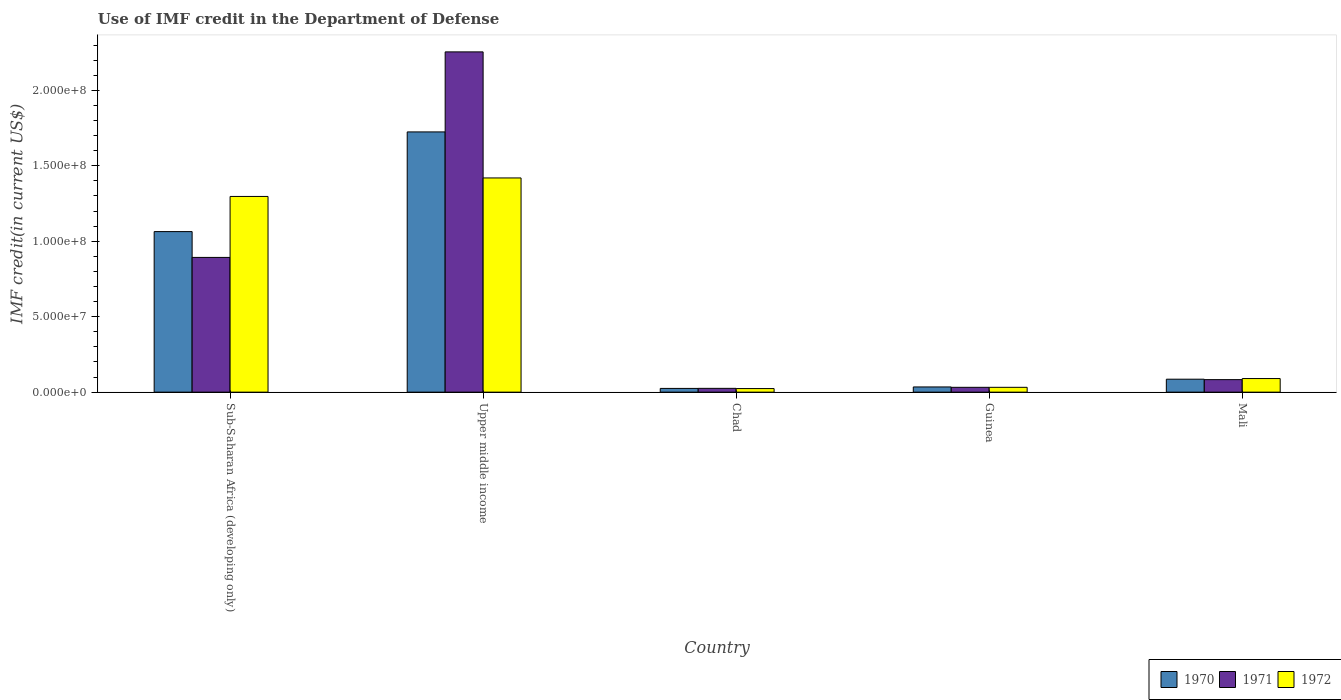Are the number of bars per tick equal to the number of legend labels?
Provide a succinct answer. Yes. Are the number of bars on each tick of the X-axis equal?
Your answer should be very brief. Yes. How many bars are there on the 2nd tick from the left?
Your answer should be compact. 3. What is the label of the 2nd group of bars from the left?
Your answer should be compact. Upper middle income. What is the IMF credit in the Department of Defense in 1972 in Upper middle income?
Keep it short and to the point. 1.42e+08. Across all countries, what is the maximum IMF credit in the Department of Defense in 1972?
Provide a short and direct response. 1.42e+08. Across all countries, what is the minimum IMF credit in the Department of Defense in 1970?
Provide a short and direct response. 2.47e+06. In which country was the IMF credit in the Department of Defense in 1971 maximum?
Offer a terse response. Upper middle income. In which country was the IMF credit in the Department of Defense in 1972 minimum?
Provide a succinct answer. Chad. What is the total IMF credit in the Department of Defense in 1970 in the graph?
Your response must be concise. 2.93e+08. What is the difference between the IMF credit in the Department of Defense in 1971 in Guinea and that in Mali?
Keep it short and to the point. -5.09e+06. What is the difference between the IMF credit in the Department of Defense in 1970 in Sub-Saharan Africa (developing only) and the IMF credit in the Department of Defense in 1971 in Mali?
Offer a very short reply. 9.81e+07. What is the average IMF credit in the Department of Defense in 1970 per country?
Ensure brevity in your answer.  5.87e+07. What is the difference between the IMF credit in the Department of Defense of/in 1971 and IMF credit in the Department of Defense of/in 1972 in Chad?
Your response must be concise. 1.52e+05. In how many countries, is the IMF credit in the Department of Defense in 1971 greater than 70000000 US$?
Offer a very short reply. 2. What is the ratio of the IMF credit in the Department of Defense in 1971 in Chad to that in Sub-Saharan Africa (developing only)?
Provide a short and direct response. 0.03. What is the difference between the highest and the second highest IMF credit in the Department of Defense in 1971?
Keep it short and to the point. 1.36e+08. What is the difference between the highest and the lowest IMF credit in the Department of Defense in 1972?
Your answer should be very brief. 1.40e+08. In how many countries, is the IMF credit in the Department of Defense in 1971 greater than the average IMF credit in the Department of Defense in 1971 taken over all countries?
Your answer should be compact. 2. What does the 3rd bar from the left in Guinea represents?
Make the answer very short. 1972. Are all the bars in the graph horizontal?
Keep it short and to the point. No. What is the difference between two consecutive major ticks on the Y-axis?
Provide a short and direct response. 5.00e+07. Are the values on the major ticks of Y-axis written in scientific E-notation?
Your response must be concise. Yes. Does the graph contain grids?
Your answer should be very brief. No. Where does the legend appear in the graph?
Offer a terse response. Bottom right. How are the legend labels stacked?
Provide a short and direct response. Horizontal. What is the title of the graph?
Your answer should be very brief. Use of IMF credit in the Department of Defense. What is the label or title of the Y-axis?
Your answer should be very brief. IMF credit(in current US$). What is the IMF credit(in current US$) of 1970 in Sub-Saharan Africa (developing only)?
Offer a terse response. 1.06e+08. What is the IMF credit(in current US$) of 1971 in Sub-Saharan Africa (developing only)?
Your answer should be very brief. 8.93e+07. What is the IMF credit(in current US$) of 1972 in Sub-Saharan Africa (developing only)?
Your answer should be compact. 1.30e+08. What is the IMF credit(in current US$) in 1970 in Upper middle income?
Your answer should be compact. 1.72e+08. What is the IMF credit(in current US$) of 1971 in Upper middle income?
Offer a terse response. 2.25e+08. What is the IMF credit(in current US$) in 1972 in Upper middle income?
Provide a succinct answer. 1.42e+08. What is the IMF credit(in current US$) of 1970 in Chad?
Provide a short and direct response. 2.47e+06. What is the IMF credit(in current US$) of 1971 in Chad?
Keep it short and to the point. 2.52e+06. What is the IMF credit(in current US$) in 1972 in Chad?
Make the answer very short. 2.37e+06. What is the IMF credit(in current US$) in 1970 in Guinea?
Provide a short and direct response. 3.45e+06. What is the IMF credit(in current US$) of 1971 in Guinea?
Your response must be concise. 3.20e+06. What is the IMF credit(in current US$) of 1972 in Guinea?
Ensure brevity in your answer.  3.20e+06. What is the IMF credit(in current US$) of 1970 in Mali?
Keep it short and to the point. 8.58e+06. What is the IMF credit(in current US$) in 1971 in Mali?
Ensure brevity in your answer.  8.30e+06. What is the IMF credit(in current US$) in 1972 in Mali?
Your answer should be very brief. 9.01e+06. Across all countries, what is the maximum IMF credit(in current US$) in 1970?
Offer a very short reply. 1.72e+08. Across all countries, what is the maximum IMF credit(in current US$) in 1971?
Your answer should be very brief. 2.25e+08. Across all countries, what is the maximum IMF credit(in current US$) in 1972?
Provide a succinct answer. 1.42e+08. Across all countries, what is the minimum IMF credit(in current US$) of 1970?
Offer a terse response. 2.47e+06. Across all countries, what is the minimum IMF credit(in current US$) in 1971?
Offer a terse response. 2.52e+06. Across all countries, what is the minimum IMF credit(in current US$) in 1972?
Make the answer very short. 2.37e+06. What is the total IMF credit(in current US$) in 1970 in the graph?
Your answer should be compact. 2.93e+08. What is the total IMF credit(in current US$) of 1971 in the graph?
Your response must be concise. 3.29e+08. What is the total IMF credit(in current US$) in 1972 in the graph?
Provide a succinct answer. 2.86e+08. What is the difference between the IMF credit(in current US$) in 1970 in Sub-Saharan Africa (developing only) and that in Upper middle income?
Your answer should be compact. -6.61e+07. What is the difference between the IMF credit(in current US$) in 1971 in Sub-Saharan Africa (developing only) and that in Upper middle income?
Your response must be concise. -1.36e+08. What is the difference between the IMF credit(in current US$) in 1972 in Sub-Saharan Africa (developing only) and that in Upper middle income?
Offer a terse response. -1.23e+07. What is the difference between the IMF credit(in current US$) of 1970 in Sub-Saharan Africa (developing only) and that in Chad?
Your response must be concise. 1.04e+08. What is the difference between the IMF credit(in current US$) of 1971 in Sub-Saharan Africa (developing only) and that in Chad?
Your response must be concise. 8.68e+07. What is the difference between the IMF credit(in current US$) of 1972 in Sub-Saharan Africa (developing only) and that in Chad?
Offer a terse response. 1.27e+08. What is the difference between the IMF credit(in current US$) of 1970 in Sub-Saharan Africa (developing only) and that in Guinea?
Provide a short and direct response. 1.03e+08. What is the difference between the IMF credit(in current US$) in 1971 in Sub-Saharan Africa (developing only) and that in Guinea?
Keep it short and to the point. 8.61e+07. What is the difference between the IMF credit(in current US$) of 1972 in Sub-Saharan Africa (developing only) and that in Guinea?
Give a very brief answer. 1.26e+08. What is the difference between the IMF credit(in current US$) in 1970 in Sub-Saharan Africa (developing only) and that in Mali?
Provide a succinct answer. 9.78e+07. What is the difference between the IMF credit(in current US$) in 1971 in Sub-Saharan Africa (developing only) and that in Mali?
Offer a very short reply. 8.10e+07. What is the difference between the IMF credit(in current US$) of 1972 in Sub-Saharan Africa (developing only) and that in Mali?
Offer a very short reply. 1.21e+08. What is the difference between the IMF credit(in current US$) of 1970 in Upper middle income and that in Chad?
Make the answer very short. 1.70e+08. What is the difference between the IMF credit(in current US$) of 1971 in Upper middle income and that in Chad?
Keep it short and to the point. 2.23e+08. What is the difference between the IMF credit(in current US$) of 1972 in Upper middle income and that in Chad?
Ensure brevity in your answer.  1.40e+08. What is the difference between the IMF credit(in current US$) in 1970 in Upper middle income and that in Guinea?
Make the answer very short. 1.69e+08. What is the difference between the IMF credit(in current US$) in 1971 in Upper middle income and that in Guinea?
Offer a very short reply. 2.22e+08. What is the difference between the IMF credit(in current US$) of 1972 in Upper middle income and that in Guinea?
Your answer should be very brief. 1.39e+08. What is the difference between the IMF credit(in current US$) of 1970 in Upper middle income and that in Mali?
Keep it short and to the point. 1.64e+08. What is the difference between the IMF credit(in current US$) in 1971 in Upper middle income and that in Mali?
Ensure brevity in your answer.  2.17e+08. What is the difference between the IMF credit(in current US$) of 1972 in Upper middle income and that in Mali?
Keep it short and to the point. 1.33e+08. What is the difference between the IMF credit(in current US$) in 1970 in Chad and that in Guinea?
Your answer should be very brief. -9.80e+05. What is the difference between the IMF credit(in current US$) in 1971 in Chad and that in Guinea?
Ensure brevity in your answer.  -6.84e+05. What is the difference between the IMF credit(in current US$) in 1972 in Chad and that in Guinea?
Your response must be concise. -8.36e+05. What is the difference between the IMF credit(in current US$) in 1970 in Chad and that in Mali?
Keep it short and to the point. -6.11e+06. What is the difference between the IMF credit(in current US$) in 1971 in Chad and that in Mali?
Offer a terse response. -5.78e+06. What is the difference between the IMF credit(in current US$) in 1972 in Chad and that in Mali?
Your response must be concise. -6.64e+06. What is the difference between the IMF credit(in current US$) in 1970 in Guinea and that in Mali?
Make the answer very short. -5.13e+06. What is the difference between the IMF credit(in current US$) in 1971 in Guinea and that in Mali?
Your response must be concise. -5.09e+06. What is the difference between the IMF credit(in current US$) of 1972 in Guinea and that in Mali?
Give a very brief answer. -5.81e+06. What is the difference between the IMF credit(in current US$) of 1970 in Sub-Saharan Africa (developing only) and the IMF credit(in current US$) of 1971 in Upper middle income?
Make the answer very short. -1.19e+08. What is the difference between the IMF credit(in current US$) in 1970 in Sub-Saharan Africa (developing only) and the IMF credit(in current US$) in 1972 in Upper middle income?
Keep it short and to the point. -3.56e+07. What is the difference between the IMF credit(in current US$) in 1971 in Sub-Saharan Africa (developing only) and the IMF credit(in current US$) in 1972 in Upper middle income?
Provide a short and direct response. -5.27e+07. What is the difference between the IMF credit(in current US$) of 1970 in Sub-Saharan Africa (developing only) and the IMF credit(in current US$) of 1971 in Chad?
Make the answer very short. 1.04e+08. What is the difference between the IMF credit(in current US$) of 1970 in Sub-Saharan Africa (developing only) and the IMF credit(in current US$) of 1972 in Chad?
Give a very brief answer. 1.04e+08. What is the difference between the IMF credit(in current US$) of 1971 in Sub-Saharan Africa (developing only) and the IMF credit(in current US$) of 1972 in Chad?
Provide a short and direct response. 8.69e+07. What is the difference between the IMF credit(in current US$) in 1970 in Sub-Saharan Africa (developing only) and the IMF credit(in current US$) in 1971 in Guinea?
Your response must be concise. 1.03e+08. What is the difference between the IMF credit(in current US$) of 1970 in Sub-Saharan Africa (developing only) and the IMF credit(in current US$) of 1972 in Guinea?
Provide a short and direct response. 1.03e+08. What is the difference between the IMF credit(in current US$) in 1971 in Sub-Saharan Africa (developing only) and the IMF credit(in current US$) in 1972 in Guinea?
Your answer should be very brief. 8.61e+07. What is the difference between the IMF credit(in current US$) of 1970 in Sub-Saharan Africa (developing only) and the IMF credit(in current US$) of 1971 in Mali?
Your answer should be very brief. 9.81e+07. What is the difference between the IMF credit(in current US$) in 1970 in Sub-Saharan Africa (developing only) and the IMF credit(in current US$) in 1972 in Mali?
Provide a succinct answer. 9.74e+07. What is the difference between the IMF credit(in current US$) in 1971 in Sub-Saharan Africa (developing only) and the IMF credit(in current US$) in 1972 in Mali?
Ensure brevity in your answer.  8.03e+07. What is the difference between the IMF credit(in current US$) in 1970 in Upper middle income and the IMF credit(in current US$) in 1971 in Chad?
Provide a succinct answer. 1.70e+08. What is the difference between the IMF credit(in current US$) in 1970 in Upper middle income and the IMF credit(in current US$) in 1972 in Chad?
Your answer should be compact. 1.70e+08. What is the difference between the IMF credit(in current US$) in 1971 in Upper middle income and the IMF credit(in current US$) in 1972 in Chad?
Offer a terse response. 2.23e+08. What is the difference between the IMF credit(in current US$) in 1970 in Upper middle income and the IMF credit(in current US$) in 1971 in Guinea?
Make the answer very short. 1.69e+08. What is the difference between the IMF credit(in current US$) in 1970 in Upper middle income and the IMF credit(in current US$) in 1972 in Guinea?
Your answer should be very brief. 1.69e+08. What is the difference between the IMF credit(in current US$) in 1971 in Upper middle income and the IMF credit(in current US$) in 1972 in Guinea?
Ensure brevity in your answer.  2.22e+08. What is the difference between the IMF credit(in current US$) in 1970 in Upper middle income and the IMF credit(in current US$) in 1971 in Mali?
Provide a succinct answer. 1.64e+08. What is the difference between the IMF credit(in current US$) of 1970 in Upper middle income and the IMF credit(in current US$) of 1972 in Mali?
Your answer should be very brief. 1.63e+08. What is the difference between the IMF credit(in current US$) in 1971 in Upper middle income and the IMF credit(in current US$) in 1972 in Mali?
Offer a terse response. 2.16e+08. What is the difference between the IMF credit(in current US$) in 1970 in Chad and the IMF credit(in current US$) in 1971 in Guinea?
Offer a very short reply. -7.33e+05. What is the difference between the IMF credit(in current US$) of 1970 in Chad and the IMF credit(in current US$) of 1972 in Guinea?
Provide a short and direct response. -7.33e+05. What is the difference between the IMF credit(in current US$) in 1971 in Chad and the IMF credit(in current US$) in 1972 in Guinea?
Make the answer very short. -6.84e+05. What is the difference between the IMF credit(in current US$) in 1970 in Chad and the IMF credit(in current US$) in 1971 in Mali?
Offer a very short reply. -5.82e+06. What is the difference between the IMF credit(in current US$) in 1970 in Chad and the IMF credit(in current US$) in 1972 in Mali?
Keep it short and to the point. -6.54e+06. What is the difference between the IMF credit(in current US$) in 1971 in Chad and the IMF credit(in current US$) in 1972 in Mali?
Provide a succinct answer. -6.49e+06. What is the difference between the IMF credit(in current US$) in 1970 in Guinea and the IMF credit(in current US$) in 1971 in Mali?
Make the answer very short. -4.84e+06. What is the difference between the IMF credit(in current US$) of 1970 in Guinea and the IMF credit(in current US$) of 1972 in Mali?
Offer a very short reply. -5.56e+06. What is the difference between the IMF credit(in current US$) of 1971 in Guinea and the IMF credit(in current US$) of 1972 in Mali?
Your answer should be compact. -5.81e+06. What is the average IMF credit(in current US$) in 1970 per country?
Offer a terse response. 5.87e+07. What is the average IMF credit(in current US$) in 1971 per country?
Your answer should be very brief. 6.58e+07. What is the average IMF credit(in current US$) in 1972 per country?
Offer a terse response. 5.72e+07. What is the difference between the IMF credit(in current US$) of 1970 and IMF credit(in current US$) of 1971 in Sub-Saharan Africa (developing only)?
Make the answer very short. 1.71e+07. What is the difference between the IMF credit(in current US$) in 1970 and IMF credit(in current US$) in 1972 in Sub-Saharan Africa (developing only)?
Provide a succinct answer. -2.33e+07. What is the difference between the IMF credit(in current US$) in 1971 and IMF credit(in current US$) in 1972 in Sub-Saharan Africa (developing only)?
Ensure brevity in your answer.  -4.04e+07. What is the difference between the IMF credit(in current US$) in 1970 and IMF credit(in current US$) in 1971 in Upper middle income?
Offer a very short reply. -5.30e+07. What is the difference between the IMF credit(in current US$) in 1970 and IMF credit(in current US$) in 1972 in Upper middle income?
Make the answer very short. 3.05e+07. What is the difference between the IMF credit(in current US$) in 1971 and IMF credit(in current US$) in 1972 in Upper middle income?
Offer a terse response. 8.35e+07. What is the difference between the IMF credit(in current US$) in 1970 and IMF credit(in current US$) in 1971 in Chad?
Keep it short and to the point. -4.90e+04. What is the difference between the IMF credit(in current US$) in 1970 and IMF credit(in current US$) in 1972 in Chad?
Offer a very short reply. 1.03e+05. What is the difference between the IMF credit(in current US$) in 1971 and IMF credit(in current US$) in 1972 in Chad?
Provide a short and direct response. 1.52e+05. What is the difference between the IMF credit(in current US$) in 1970 and IMF credit(in current US$) in 1971 in Guinea?
Keep it short and to the point. 2.47e+05. What is the difference between the IMF credit(in current US$) in 1970 and IMF credit(in current US$) in 1972 in Guinea?
Your response must be concise. 2.47e+05. What is the difference between the IMF credit(in current US$) of 1971 and IMF credit(in current US$) of 1972 in Guinea?
Provide a short and direct response. 0. What is the difference between the IMF credit(in current US$) of 1970 and IMF credit(in current US$) of 1971 in Mali?
Ensure brevity in your answer.  2.85e+05. What is the difference between the IMF credit(in current US$) of 1970 and IMF credit(in current US$) of 1972 in Mali?
Keep it short and to the point. -4.31e+05. What is the difference between the IMF credit(in current US$) in 1971 and IMF credit(in current US$) in 1972 in Mali?
Your response must be concise. -7.16e+05. What is the ratio of the IMF credit(in current US$) of 1970 in Sub-Saharan Africa (developing only) to that in Upper middle income?
Ensure brevity in your answer.  0.62. What is the ratio of the IMF credit(in current US$) in 1971 in Sub-Saharan Africa (developing only) to that in Upper middle income?
Offer a terse response. 0.4. What is the ratio of the IMF credit(in current US$) in 1972 in Sub-Saharan Africa (developing only) to that in Upper middle income?
Provide a succinct answer. 0.91. What is the ratio of the IMF credit(in current US$) in 1970 in Sub-Saharan Africa (developing only) to that in Chad?
Provide a succinct answer. 43.07. What is the ratio of the IMF credit(in current US$) in 1971 in Sub-Saharan Africa (developing only) to that in Chad?
Offer a terse response. 35.45. What is the ratio of the IMF credit(in current US$) in 1972 in Sub-Saharan Africa (developing only) to that in Chad?
Provide a short and direct response. 54.79. What is the ratio of the IMF credit(in current US$) in 1970 in Sub-Saharan Africa (developing only) to that in Guinea?
Keep it short and to the point. 30.84. What is the ratio of the IMF credit(in current US$) in 1971 in Sub-Saharan Africa (developing only) to that in Guinea?
Your response must be concise. 27.88. What is the ratio of the IMF credit(in current US$) of 1972 in Sub-Saharan Africa (developing only) to that in Guinea?
Ensure brevity in your answer.  40.49. What is the ratio of the IMF credit(in current US$) of 1970 in Sub-Saharan Africa (developing only) to that in Mali?
Offer a very short reply. 12.4. What is the ratio of the IMF credit(in current US$) of 1971 in Sub-Saharan Africa (developing only) to that in Mali?
Ensure brevity in your answer.  10.76. What is the ratio of the IMF credit(in current US$) in 1972 in Sub-Saharan Africa (developing only) to that in Mali?
Give a very brief answer. 14.39. What is the ratio of the IMF credit(in current US$) of 1970 in Upper middle income to that in Chad?
Your response must be concise. 69.82. What is the ratio of the IMF credit(in current US$) in 1971 in Upper middle income to that in Chad?
Make the answer very short. 89.51. What is the ratio of the IMF credit(in current US$) in 1972 in Upper middle income to that in Chad?
Ensure brevity in your answer.  59.97. What is the ratio of the IMF credit(in current US$) of 1970 in Upper middle income to that in Guinea?
Offer a very short reply. 49.99. What is the ratio of the IMF credit(in current US$) in 1971 in Upper middle income to that in Guinea?
Your answer should be very brief. 70.4. What is the ratio of the IMF credit(in current US$) of 1972 in Upper middle income to that in Guinea?
Offer a terse response. 44.32. What is the ratio of the IMF credit(in current US$) in 1970 in Upper middle income to that in Mali?
Keep it short and to the point. 20.1. What is the ratio of the IMF credit(in current US$) in 1971 in Upper middle income to that in Mali?
Ensure brevity in your answer.  27.18. What is the ratio of the IMF credit(in current US$) in 1972 in Upper middle income to that in Mali?
Provide a short and direct response. 15.75. What is the ratio of the IMF credit(in current US$) in 1970 in Chad to that in Guinea?
Your answer should be very brief. 0.72. What is the ratio of the IMF credit(in current US$) in 1971 in Chad to that in Guinea?
Provide a succinct answer. 0.79. What is the ratio of the IMF credit(in current US$) of 1972 in Chad to that in Guinea?
Offer a terse response. 0.74. What is the ratio of the IMF credit(in current US$) of 1970 in Chad to that in Mali?
Keep it short and to the point. 0.29. What is the ratio of the IMF credit(in current US$) in 1971 in Chad to that in Mali?
Keep it short and to the point. 0.3. What is the ratio of the IMF credit(in current US$) in 1972 in Chad to that in Mali?
Your answer should be compact. 0.26. What is the ratio of the IMF credit(in current US$) in 1970 in Guinea to that in Mali?
Give a very brief answer. 0.4. What is the ratio of the IMF credit(in current US$) in 1971 in Guinea to that in Mali?
Offer a terse response. 0.39. What is the ratio of the IMF credit(in current US$) in 1972 in Guinea to that in Mali?
Your response must be concise. 0.36. What is the difference between the highest and the second highest IMF credit(in current US$) in 1970?
Offer a terse response. 6.61e+07. What is the difference between the highest and the second highest IMF credit(in current US$) in 1971?
Offer a very short reply. 1.36e+08. What is the difference between the highest and the second highest IMF credit(in current US$) in 1972?
Offer a very short reply. 1.23e+07. What is the difference between the highest and the lowest IMF credit(in current US$) of 1970?
Provide a succinct answer. 1.70e+08. What is the difference between the highest and the lowest IMF credit(in current US$) of 1971?
Give a very brief answer. 2.23e+08. What is the difference between the highest and the lowest IMF credit(in current US$) of 1972?
Provide a succinct answer. 1.40e+08. 